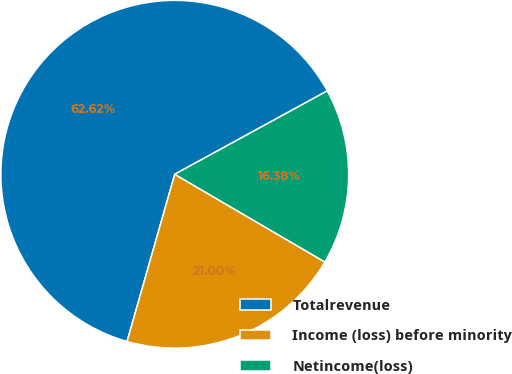Convert chart. <chart><loc_0><loc_0><loc_500><loc_500><pie_chart><fcel>Totalrevenue<fcel>Income (loss) before minority<fcel>Netincome(loss)<nl><fcel>62.61%<fcel>21.0%<fcel>16.38%<nl></chart> 